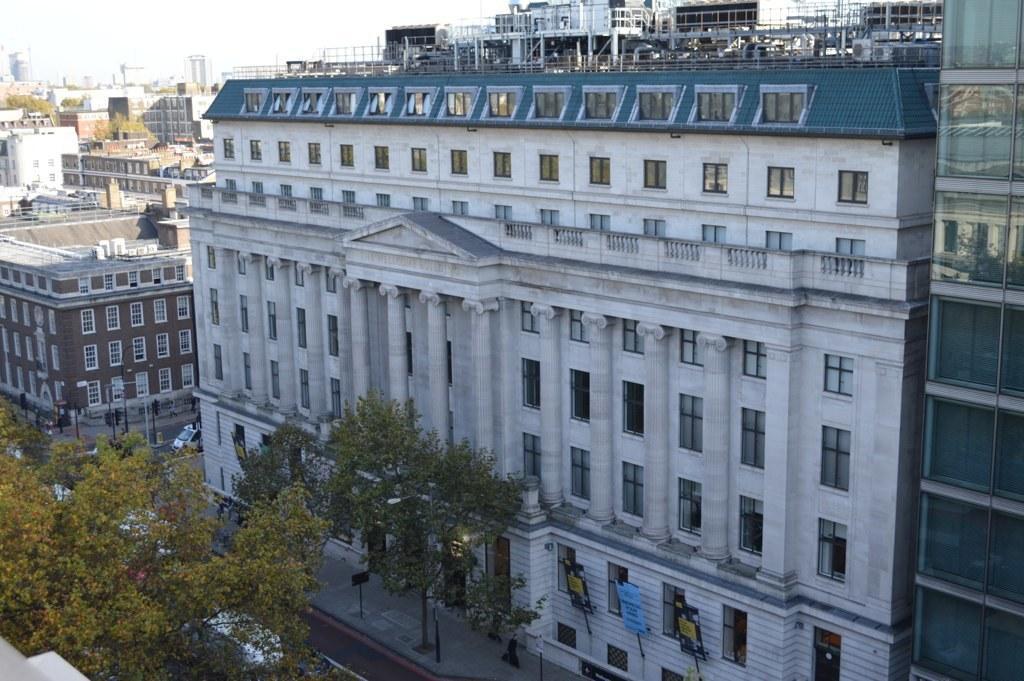Could you give a brief overview of what you see in this image? In this picture we can see buildings, on the left side there are some trees, we can see poles here, there is a vehicle here, there is the sky at the top of the picture, at the bottom there are some boards. 